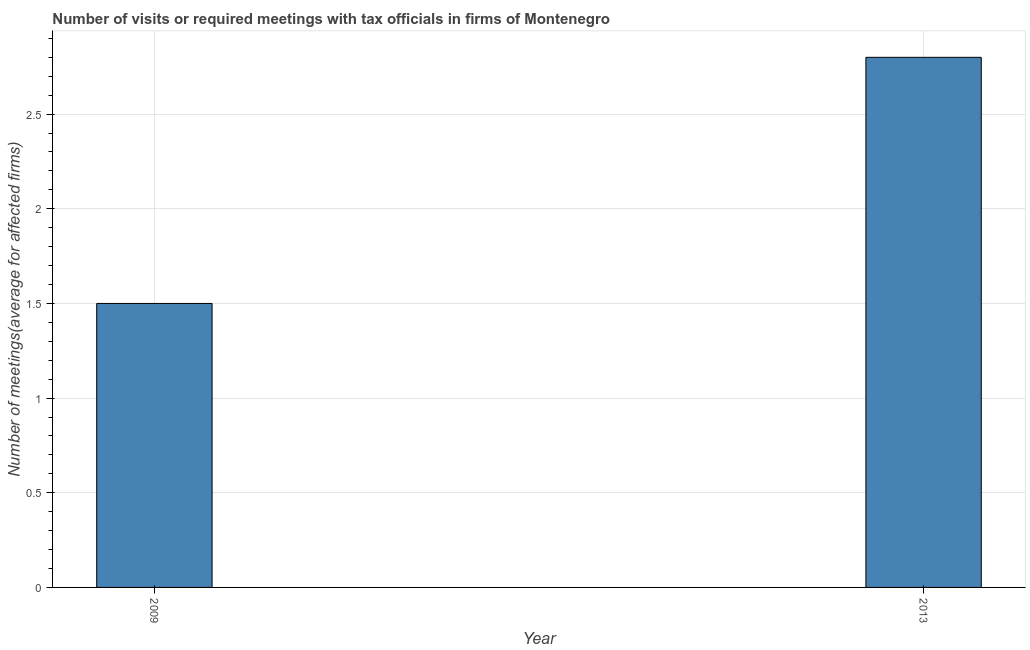Does the graph contain any zero values?
Make the answer very short. No. Does the graph contain grids?
Provide a short and direct response. Yes. What is the title of the graph?
Provide a short and direct response. Number of visits or required meetings with tax officials in firms of Montenegro. What is the label or title of the X-axis?
Make the answer very short. Year. What is the label or title of the Y-axis?
Provide a succinct answer. Number of meetings(average for affected firms). What is the number of required meetings with tax officials in 2009?
Give a very brief answer. 1.5. Across all years, what is the minimum number of required meetings with tax officials?
Ensure brevity in your answer.  1.5. In which year was the number of required meetings with tax officials minimum?
Offer a very short reply. 2009. What is the sum of the number of required meetings with tax officials?
Your answer should be very brief. 4.3. What is the difference between the number of required meetings with tax officials in 2009 and 2013?
Provide a short and direct response. -1.3. What is the average number of required meetings with tax officials per year?
Provide a short and direct response. 2.15. What is the median number of required meetings with tax officials?
Offer a terse response. 2.15. What is the ratio of the number of required meetings with tax officials in 2009 to that in 2013?
Make the answer very short. 0.54. Is the number of required meetings with tax officials in 2009 less than that in 2013?
Make the answer very short. Yes. In how many years, is the number of required meetings with tax officials greater than the average number of required meetings with tax officials taken over all years?
Ensure brevity in your answer.  1. How many bars are there?
Your answer should be very brief. 2. Are all the bars in the graph horizontal?
Your answer should be very brief. No. Are the values on the major ticks of Y-axis written in scientific E-notation?
Provide a short and direct response. No. What is the Number of meetings(average for affected firms) of 2009?
Make the answer very short. 1.5. What is the difference between the Number of meetings(average for affected firms) in 2009 and 2013?
Keep it short and to the point. -1.3. What is the ratio of the Number of meetings(average for affected firms) in 2009 to that in 2013?
Provide a succinct answer. 0.54. 